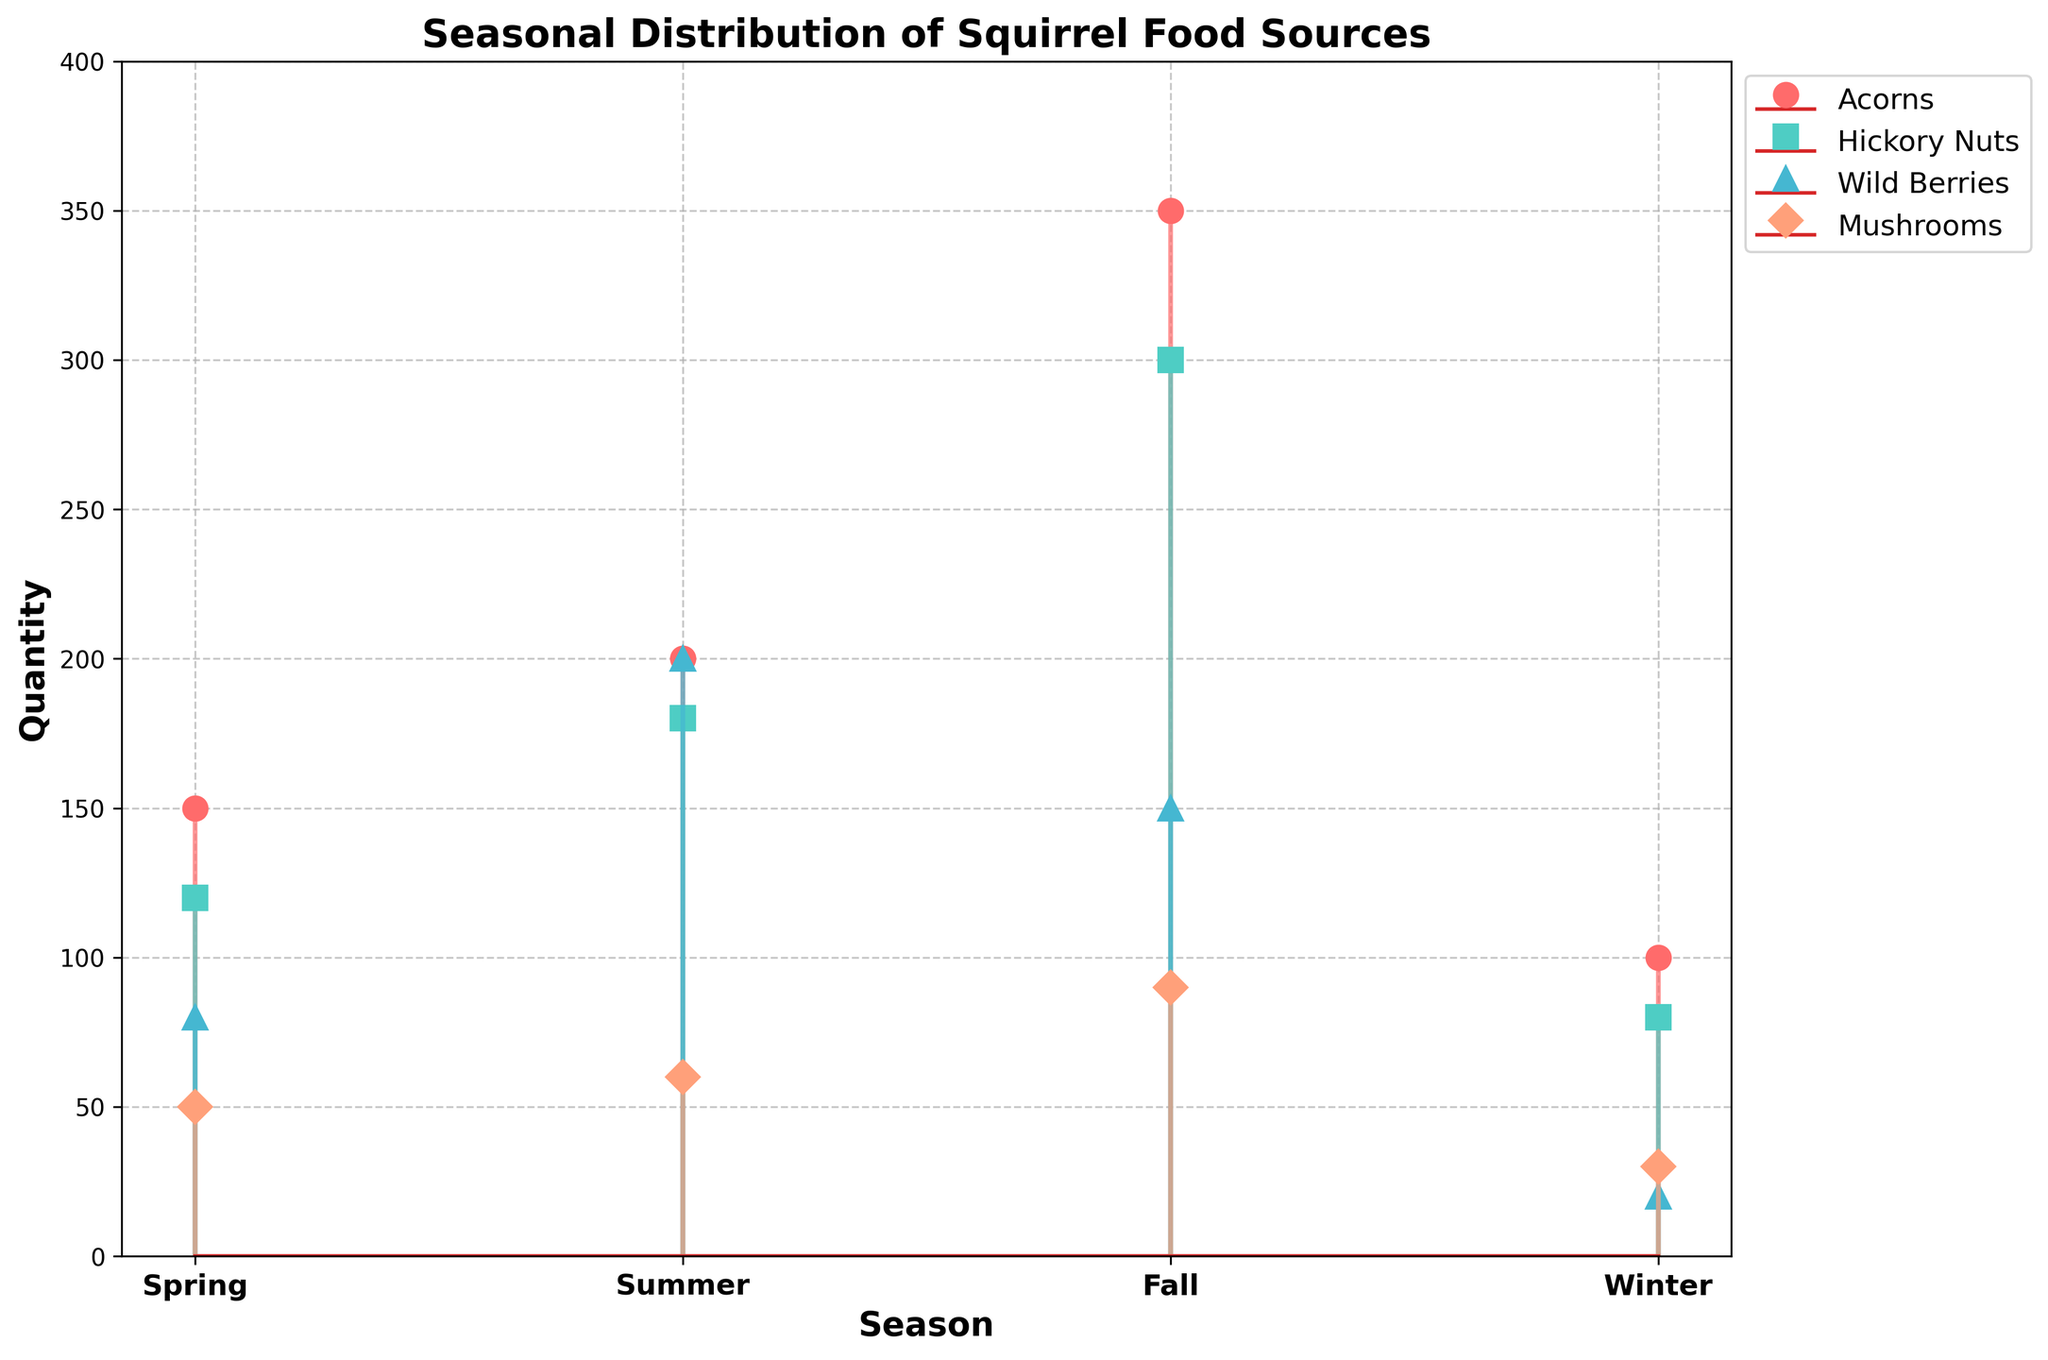What is the title of the figure? The title is displayed at the top of the figure and reads "Seasonal Distribution of Squirrel Food Sources".
Answer: Seasonal Distribution of Squirrel Food Sources How many different food sources are shown in the figure? The figure displays four different food sources, which are indicated by different colors and markers in the legend.
Answer: Four Which food source has the highest quantity in the Fall? The food source with the highest quantity in the Fall can be identified by looking at the Fall data points; Acorns have the highest quantity at 350.
Answer: Acorns What is the quantity of wild berries in the Winter? To find the quantity of wild berries in the Winter, refer to the marker for wild berries (green triangle) in the Winter section; it's shown at 20.
Answer: 20 What's the total quantity of food sources available in the Summer? Sum the quantities of all food sources in the Summer: 200 (Acorns) + 180 (Hickory Nuts) + 200 (Wild Berries) + 60 (Mushrooms) = 640.
Answer: 640 Which season has the lowest quantity of mushrooms? Compare the quantities of mushrooms (purple diamonds) across all seasons; Winter has the lowest at 30.
Answer: Winter How does the quantity of Hickory Nuts in the Spring compare to that in the Fall? The quantity of Hickory Nuts in the Spring (red squares) is 120, while in the Fall it is 300. The quantity in the Fall is greater than in the Spring by 180.
Answer: Fall is greater by 180 Which food source has the most consistent quantity throughout the year? Assess the fluctuations in the quantities of each food source across all seasons; Acorns (dark red circles) are most consistent, ranging from 100 to 350.
Answer: Acorns What's the average quantity of Mushrooms across all seasons? Sum the quantities of mushrooms for each season: 50 (Spring) + 60 (Summer) + 90 (Fall) + 30 (Winter) = 230. Then divide by 4 (number of seasons): 230 / 4 = 57.5.
Answer: 57.5 